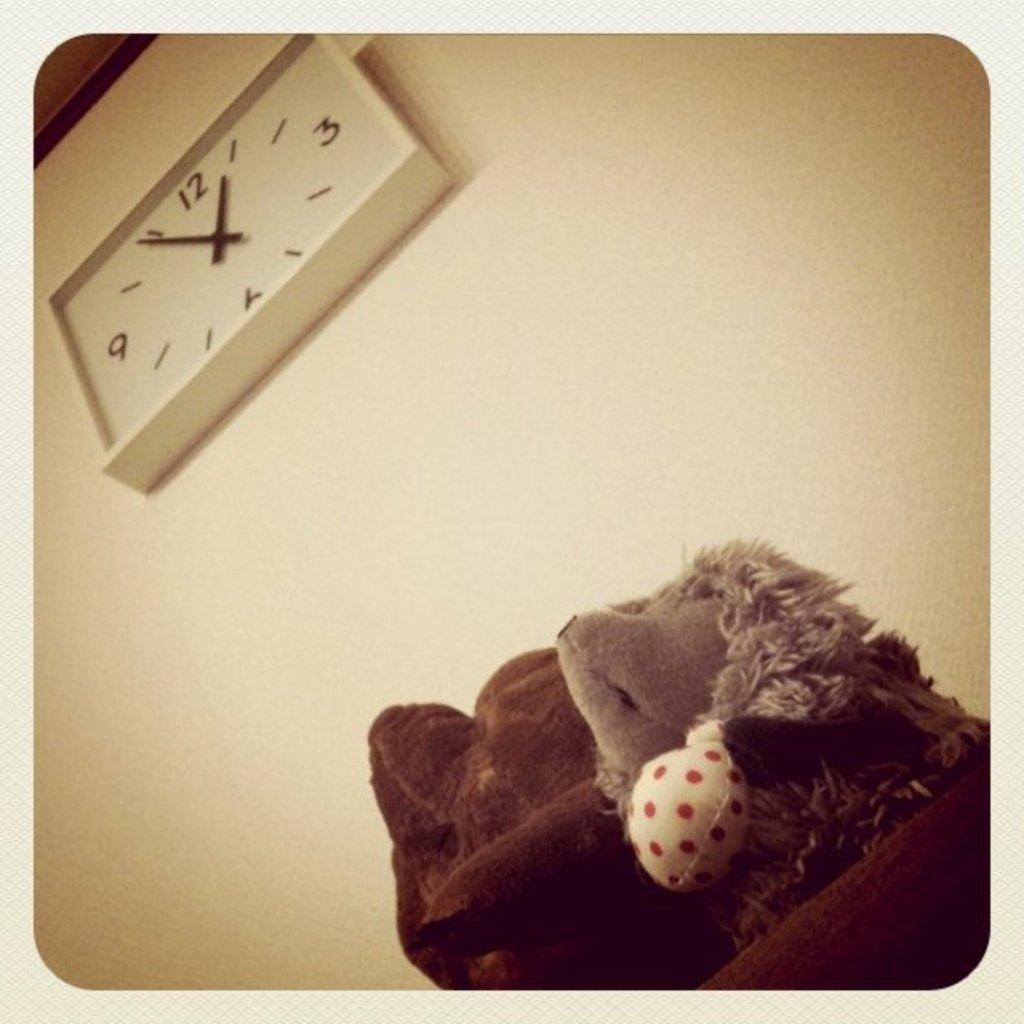What object is placed on the table in the image? There is a toy on the table in the image. What timekeeping device is visible in the image? There is a wall clock in the top left of the image. What type of debt is being discussed in the image? There is no mention of debt in the image; it features a toy on a table and a wall clock. What color is the shirt worn by the coil in the image? There is no coil or shirt present in the image. 